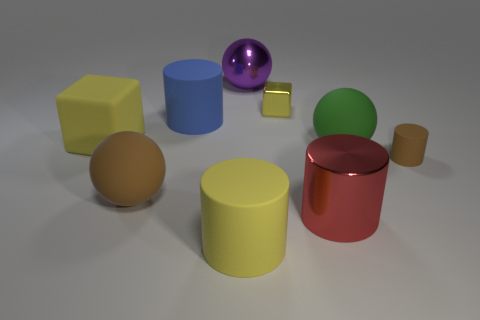Does the big cube have the same color as the tiny shiny thing?
Your answer should be compact. Yes. The brown rubber object that is the same shape as the big blue matte object is what size?
Your answer should be very brief. Small. What number of other objects are the same material as the big cube?
Provide a short and direct response. 5. What material is the large brown ball?
Provide a short and direct response. Rubber. There is a ball that is left of the purple shiny sphere; is its color the same as the big metallic thing that is in front of the tiny matte object?
Make the answer very short. No. Is the number of large rubber spheres in front of the red cylinder greater than the number of tiny rubber cylinders?
Give a very brief answer. No. What number of other things are the same color as the big rubber block?
Give a very brief answer. 2. There is a yellow cube that is to the right of the blue cylinder; does it have the same size as the tiny cylinder?
Offer a very short reply. Yes. Are there any green rubber cubes that have the same size as the yellow rubber cylinder?
Keep it short and to the point. No. There is a tiny matte thing that is right of the green rubber thing; what color is it?
Provide a succinct answer. Brown. 